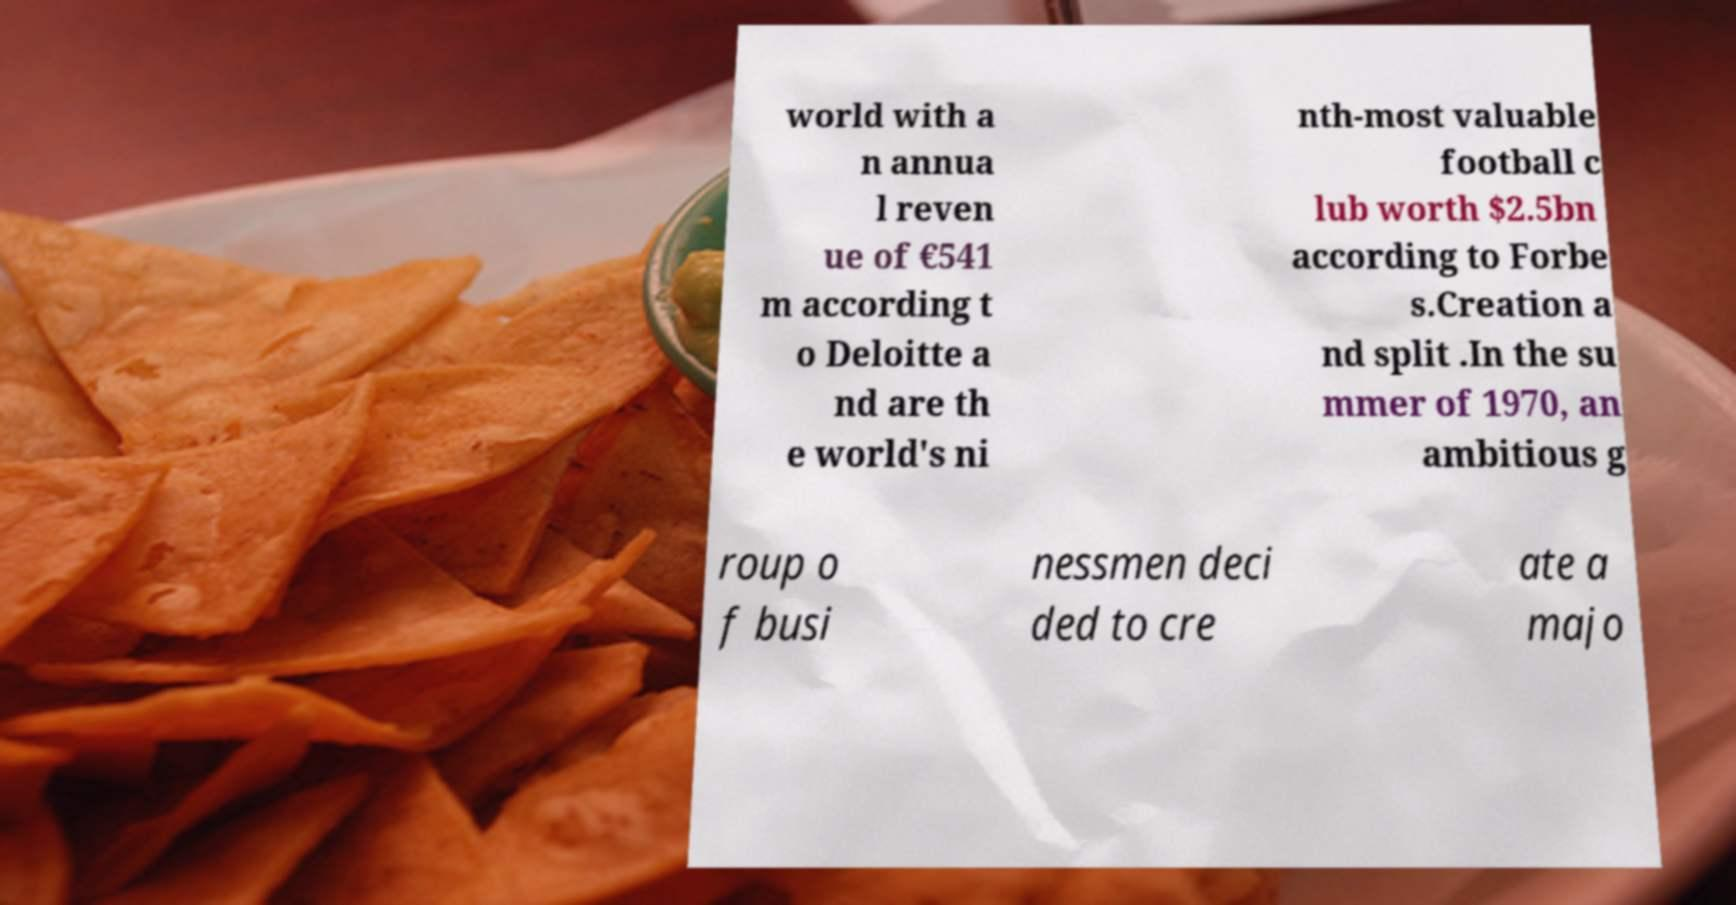Can you accurately transcribe the text from the provided image for me? world with a n annua l reven ue of €541 m according t o Deloitte a nd are th e world's ni nth-most valuable football c lub worth $2.5bn according to Forbe s.Creation a nd split .In the su mmer of 1970, an ambitious g roup o f busi nessmen deci ded to cre ate a majo 